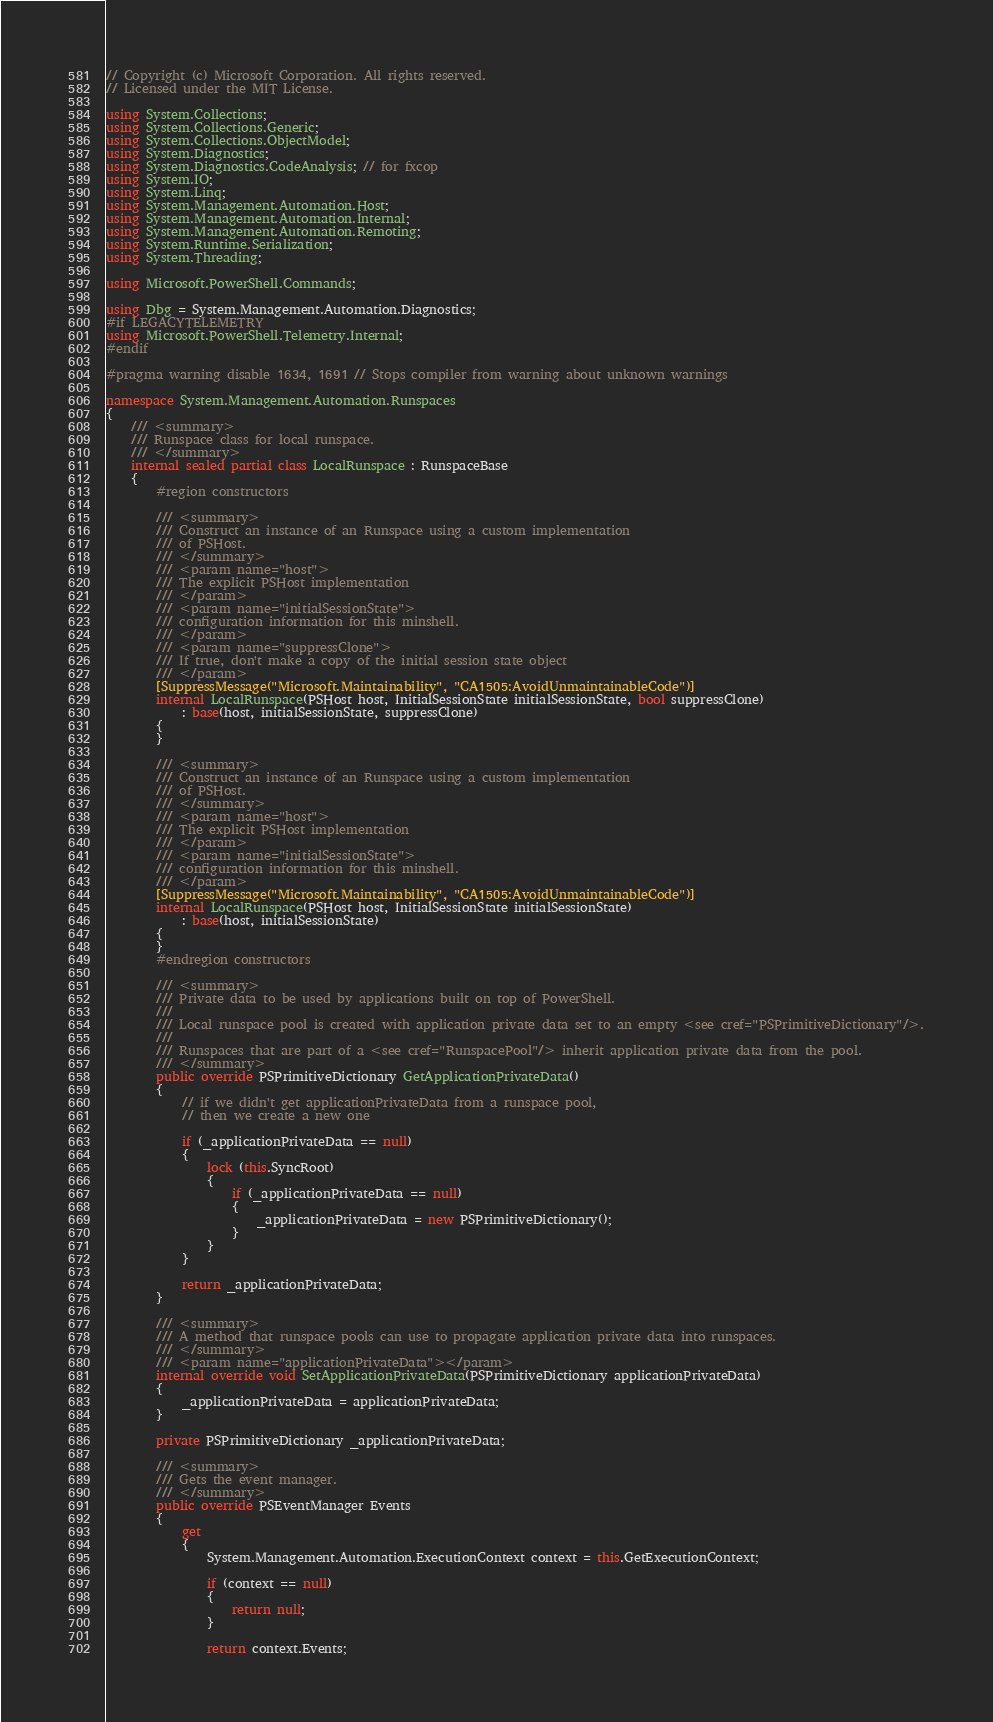<code> <loc_0><loc_0><loc_500><loc_500><_C#_>// Copyright (c) Microsoft Corporation. All rights reserved.
// Licensed under the MIT License.

using System.Collections;
using System.Collections.Generic;
using System.Collections.ObjectModel;
using System.Diagnostics;
using System.Diagnostics.CodeAnalysis; // for fxcop
using System.IO;
using System.Linq;
using System.Management.Automation.Host;
using System.Management.Automation.Internal;
using System.Management.Automation.Remoting;
using System.Runtime.Serialization;
using System.Threading;

using Microsoft.PowerShell.Commands;

using Dbg = System.Management.Automation.Diagnostics;
#if LEGACYTELEMETRY
using Microsoft.PowerShell.Telemetry.Internal;
#endif

#pragma warning disable 1634, 1691 // Stops compiler from warning about unknown warnings

namespace System.Management.Automation.Runspaces
{
    /// <summary>
    /// Runspace class for local runspace.
    /// </summary>
    internal sealed partial class LocalRunspace : RunspaceBase
    {
        #region constructors

        /// <summary>
        /// Construct an instance of an Runspace using a custom implementation
        /// of PSHost.
        /// </summary>
        /// <param name="host">
        /// The explicit PSHost implementation
        /// </param>
        /// <param name="initialSessionState">
        /// configuration information for this minshell.
        /// </param>
        /// <param name="suppressClone">
        /// If true, don't make a copy of the initial session state object
        /// </param>
        [SuppressMessage("Microsoft.Maintainability", "CA1505:AvoidUnmaintainableCode")]
        internal LocalRunspace(PSHost host, InitialSessionState initialSessionState, bool suppressClone)
            : base(host, initialSessionState, suppressClone)
        {
        }

        /// <summary>
        /// Construct an instance of an Runspace using a custom implementation
        /// of PSHost.
        /// </summary>
        /// <param name="host">
        /// The explicit PSHost implementation
        /// </param>
        /// <param name="initialSessionState">
        /// configuration information for this minshell.
        /// </param>
        [SuppressMessage("Microsoft.Maintainability", "CA1505:AvoidUnmaintainableCode")]
        internal LocalRunspace(PSHost host, InitialSessionState initialSessionState)
            : base(host, initialSessionState)
        {
        }
        #endregion constructors

        /// <summary>
        /// Private data to be used by applications built on top of PowerShell.
        ///
        /// Local runspace pool is created with application private data set to an empty <see cref="PSPrimitiveDictionary"/>.
        ///
        /// Runspaces that are part of a <see cref="RunspacePool"/> inherit application private data from the pool.
        /// </summary>
        public override PSPrimitiveDictionary GetApplicationPrivateData()
        {
            // if we didn't get applicationPrivateData from a runspace pool,
            // then we create a new one

            if (_applicationPrivateData == null)
            {
                lock (this.SyncRoot)
                {
                    if (_applicationPrivateData == null)
                    {
                        _applicationPrivateData = new PSPrimitiveDictionary();
                    }
                }
            }

            return _applicationPrivateData;
        }

        /// <summary>
        /// A method that runspace pools can use to propagate application private data into runspaces.
        /// </summary>
        /// <param name="applicationPrivateData"></param>
        internal override void SetApplicationPrivateData(PSPrimitiveDictionary applicationPrivateData)
        {
            _applicationPrivateData = applicationPrivateData;
        }

        private PSPrimitiveDictionary _applicationPrivateData;

        /// <summary>
        /// Gets the event manager.
        /// </summary>
        public override PSEventManager Events
        {
            get
            {
                System.Management.Automation.ExecutionContext context = this.GetExecutionContext;

                if (context == null)
                {
                    return null;
                }

                return context.Events;</code> 